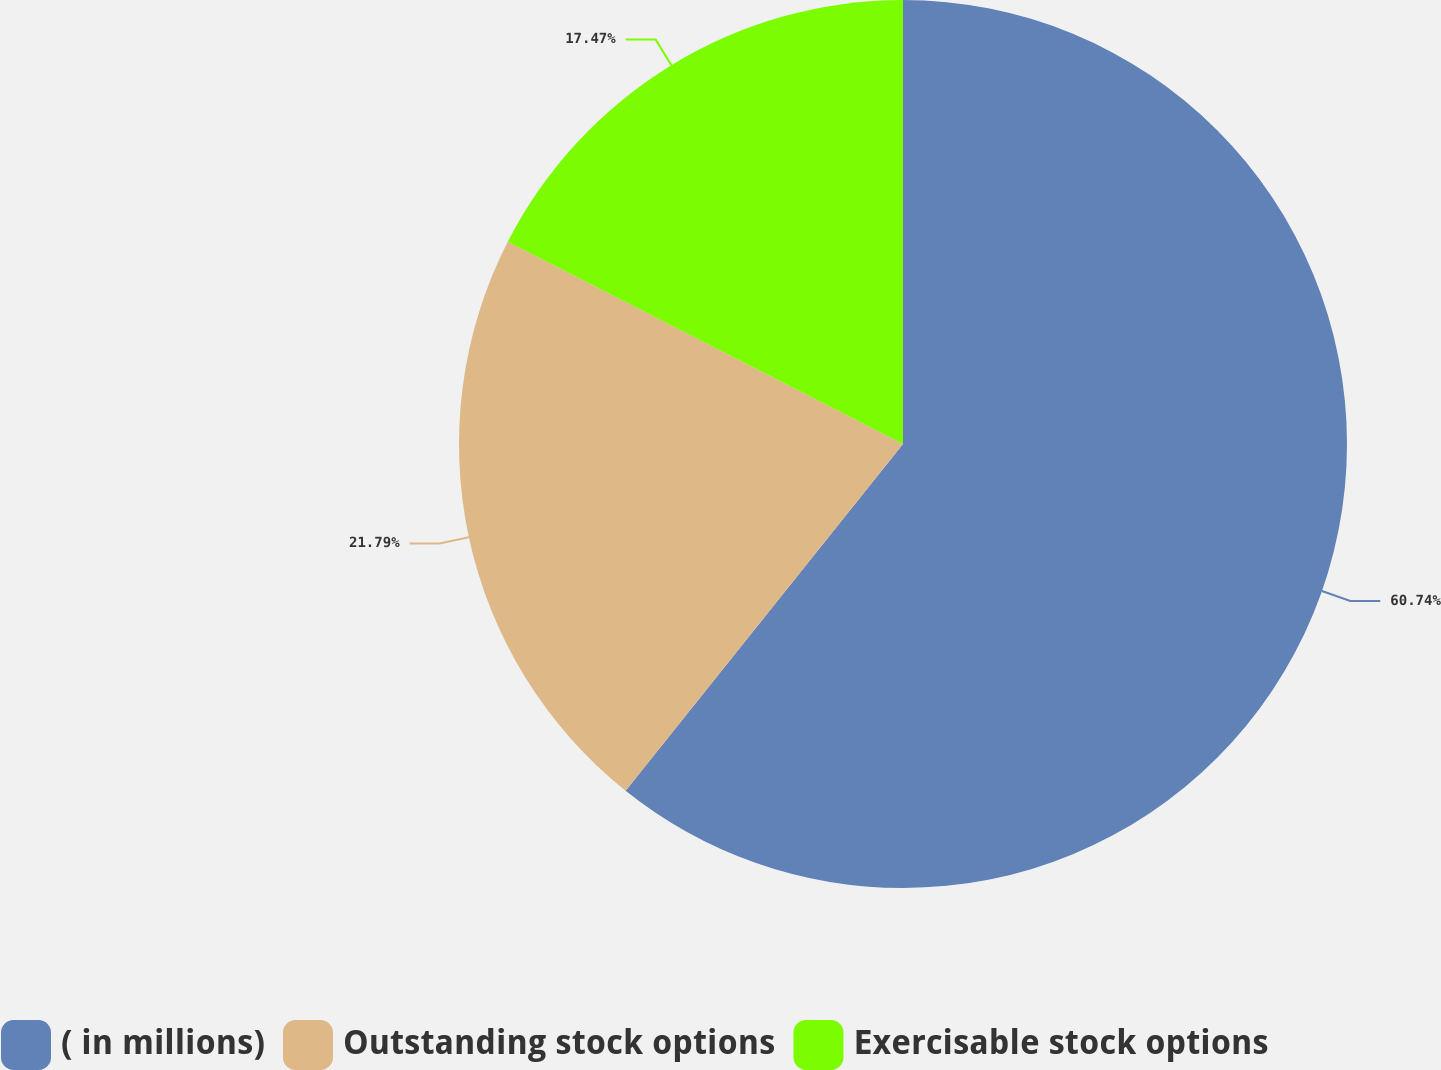<chart> <loc_0><loc_0><loc_500><loc_500><pie_chart><fcel>( in millions)<fcel>Outstanding stock options<fcel>Exercisable stock options<nl><fcel>60.74%<fcel>21.79%<fcel>17.47%<nl></chart> 